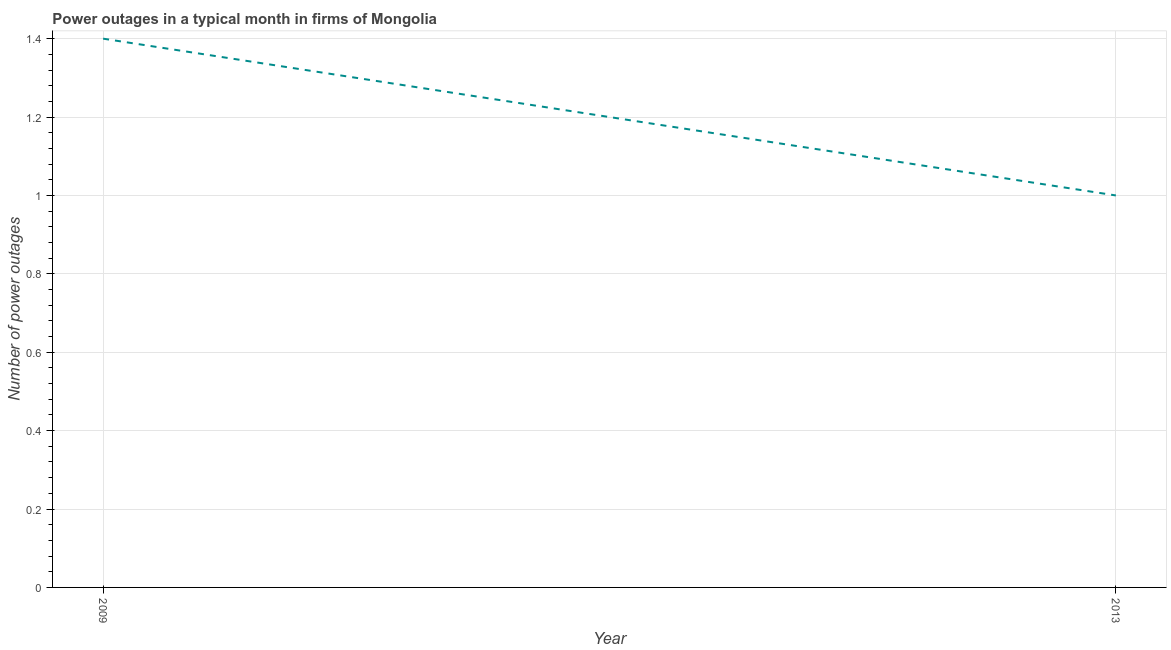In which year was the number of power outages maximum?
Make the answer very short. 2009. In which year was the number of power outages minimum?
Provide a succinct answer. 2013. What is the sum of the number of power outages?
Your answer should be compact. 2.4. What is the difference between the number of power outages in 2009 and 2013?
Provide a short and direct response. 0.4. What is the median number of power outages?
Your answer should be compact. 1.2. In how many years, is the number of power outages greater than 0.52 ?
Ensure brevity in your answer.  2. Does the number of power outages monotonically increase over the years?
Offer a terse response. No. How many years are there in the graph?
Ensure brevity in your answer.  2. Does the graph contain any zero values?
Ensure brevity in your answer.  No. Does the graph contain grids?
Give a very brief answer. Yes. What is the title of the graph?
Your answer should be compact. Power outages in a typical month in firms of Mongolia. What is the label or title of the Y-axis?
Your answer should be compact. Number of power outages. What is the difference between the Number of power outages in 2009 and 2013?
Keep it short and to the point. 0.4. What is the ratio of the Number of power outages in 2009 to that in 2013?
Your answer should be compact. 1.4. 